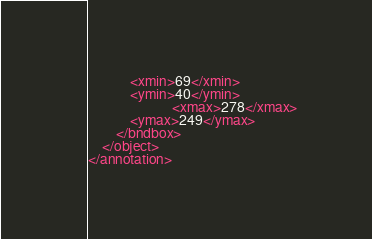<code> <loc_0><loc_0><loc_500><loc_500><_XML_>			<xmin>69</xmin>
			<ymin>40</ymin>
                        <xmax>278</xmax>
			<ymax>249</ymax>
		</bndbox>
	</object>
</annotation>
</code> 